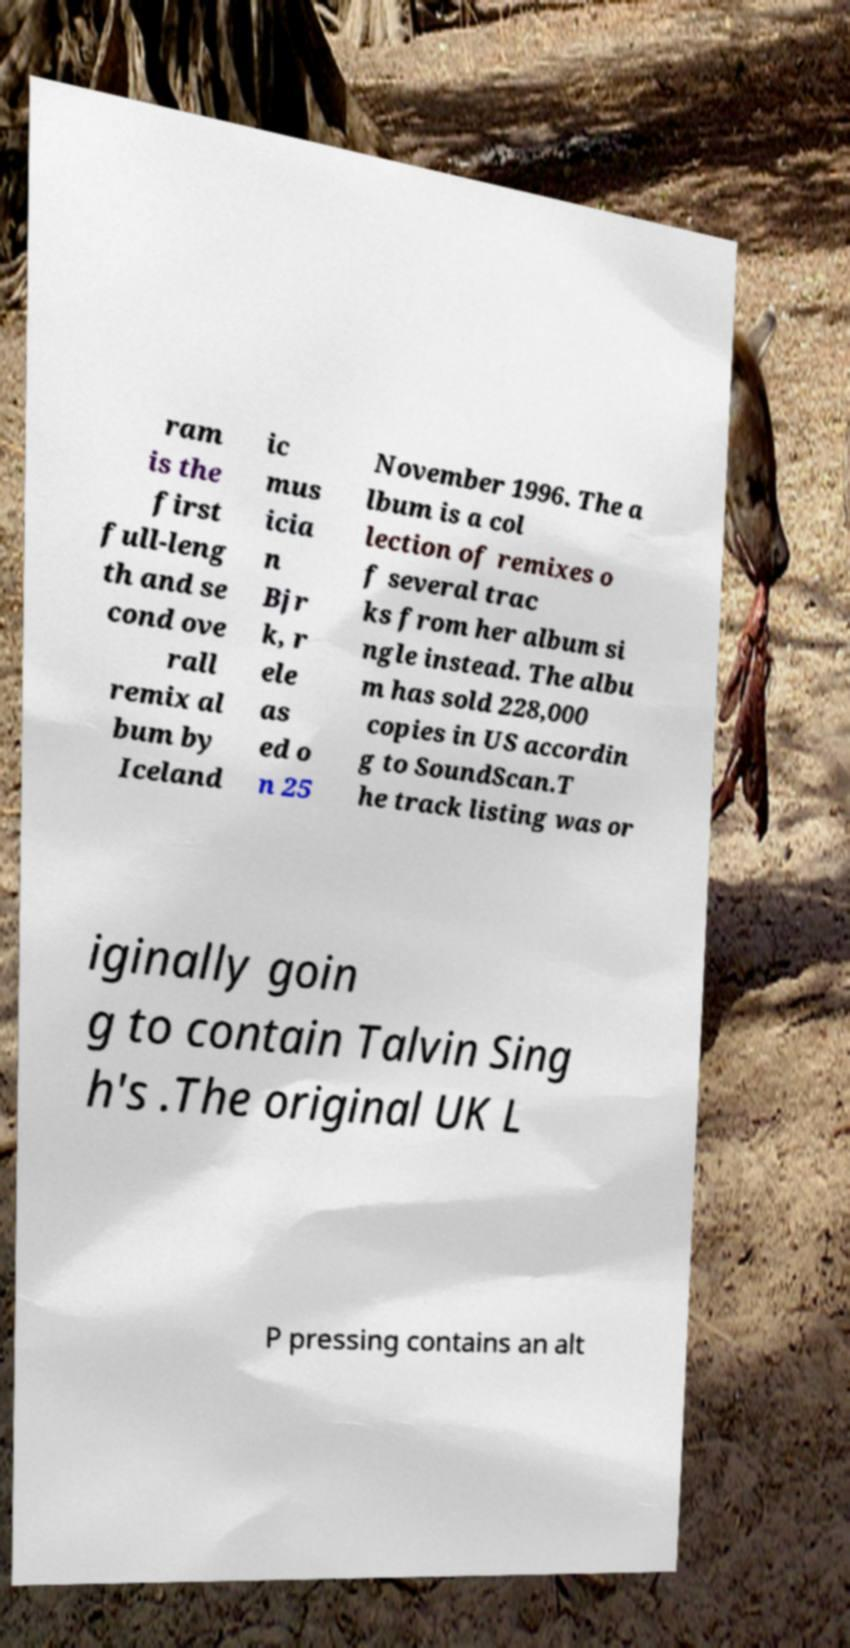There's text embedded in this image that I need extracted. Can you transcribe it verbatim? ram is the first full-leng th and se cond ove rall remix al bum by Iceland ic mus icia n Bjr k, r ele as ed o n 25 November 1996. The a lbum is a col lection of remixes o f several trac ks from her album si ngle instead. The albu m has sold 228,000 copies in US accordin g to SoundScan.T he track listing was or iginally goin g to contain Talvin Sing h's .The original UK L P pressing contains an alt 